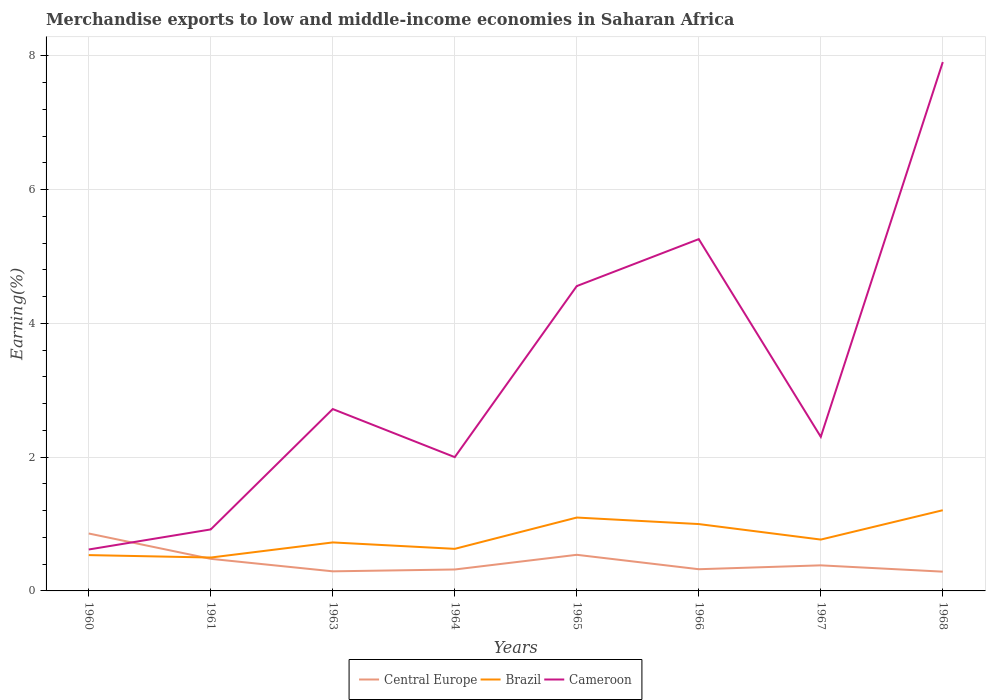Is the number of lines equal to the number of legend labels?
Your answer should be compact. Yes. Across all years, what is the maximum percentage of amount earned from merchandise exports in Cameroon?
Offer a very short reply. 0.62. What is the total percentage of amount earned from merchandise exports in Cameroon in the graph?
Your answer should be very brief. -4.34. What is the difference between the highest and the second highest percentage of amount earned from merchandise exports in Cameroon?
Give a very brief answer. 7.29. What is the difference between the highest and the lowest percentage of amount earned from merchandise exports in Cameroon?
Offer a terse response. 3. How many years are there in the graph?
Make the answer very short. 8. What is the difference between two consecutive major ticks on the Y-axis?
Offer a terse response. 2. Are the values on the major ticks of Y-axis written in scientific E-notation?
Your response must be concise. No. How are the legend labels stacked?
Ensure brevity in your answer.  Horizontal. What is the title of the graph?
Keep it short and to the point. Merchandise exports to low and middle-income economies in Saharan Africa. What is the label or title of the X-axis?
Keep it short and to the point. Years. What is the label or title of the Y-axis?
Your answer should be very brief. Earning(%). What is the Earning(%) of Central Europe in 1960?
Keep it short and to the point. 0.86. What is the Earning(%) in Brazil in 1960?
Your response must be concise. 0.54. What is the Earning(%) of Cameroon in 1960?
Provide a succinct answer. 0.62. What is the Earning(%) in Central Europe in 1961?
Give a very brief answer. 0.48. What is the Earning(%) of Brazil in 1961?
Ensure brevity in your answer.  0.5. What is the Earning(%) in Cameroon in 1961?
Your response must be concise. 0.92. What is the Earning(%) of Central Europe in 1963?
Your answer should be very brief. 0.29. What is the Earning(%) in Brazil in 1963?
Keep it short and to the point. 0.72. What is the Earning(%) of Cameroon in 1963?
Offer a terse response. 2.72. What is the Earning(%) of Central Europe in 1964?
Ensure brevity in your answer.  0.32. What is the Earning(%) in Brazil in 1964?
Offer a terse response. 0.63. What is the Earning(%) in Cameroon in 1964?
Give a very brief answer. 2. What is the Earning(%) in Central Europe in 1965?
Ensure brevity in your answer.  0.54. What is the Earning(%) of Brazil in 1965?
Provide a short and direct response. 1.1. What is the Earning(%) in Cameroon in 1965?
Provide a succinct answer. 4.56. What is the Earning(%) of Central Europe in 1966?
Make the answer very short. 0.32. What is the Earning(%) in Brazil in 1966?
Make the answer very short. 1. What is the Earning(%) of Cameroon in 1966?
Ensure brevity in your answer.  5.26. What is the Earning(%) of Central Europe in 1967?
Offer a very short reply. 0.38. What is the Earning(%) in Brazil in 1967?
Give a very brief answer. 0.77. What is the Earning(%) of Cameroon in 1967?
Your answer should be compact. 2.3. What is the Earning(%) in Central Europe in 1968?
Your answer should be very brief. 0.29. What is the Earning(%) of Brazil in 1968?
Ensure brevity in your answer.  1.21. What is the Earning(%) in Cameroon in 1968?
Provide a short and direct response. 7.91. Across all years, what is the maximum Earning(%) in Central Europe?
Your answer should be very brief. 0.86. Across all years, what is the maximum Earning(%) in Brazil?
Provide a short and direct response. 1.21. Across all years, what is the maximum Earning(%) in Cameroon?
Make the answer very short. 7.91. Across all years, what is the minimum Earning(%) in Central Europe?
Your answer should be compact. 0.29. Across all years, what is the minimum Earning(%) of Brazil?
Offer a terse response. 0.5. Across all years, what is the minimum Earning(%) of Cameroon?
Offer a very short reply. 0.62. What is the total Earning(%) in Central Europe in the graph?
Provide a succinct answer. 3.49. What is the total Earning(%) of Brazil in the graph?
Ensure brevity in your answer.  6.46. What is the total Earning(%) in Cameroon in the graph?
Your answer should be compact. 26.28. What is the difference between the Earning(%) of Central Europe in 1960 and that in 1961?
Your answer should be very brief. 0.38. What is the difference between the Earning(%) of Brazil in 1960 and that in 1961?
Provide a succinct answer. 0.04. What is the difference between the Earning(%) in Cameroon in 1960 and that in 1961?
Your answer should be compact. -0.3. What is the difference between the Earning(%) of Central Europe in 1960 and that in 1963?
Ensure brevity in your answer.  0.57. What is the difference between the Earning(%) of Brazil in 1960 and that in 1963?
Your answer should be very brief. -0.19. What is the difference between the Earning(%) of Cameroon in 1960 and that in 1963?
Provide a succinct answer. -2.1. What is the difference between the Earning(%) in Central Europe in 1960 and that in 1964?
Offer a terse response. 0.54. What is the difference between the Earning(%) in Brazil in 1960 and that in 1964?
Offer a terse response. -0.09. What is the difference between the Earning(%) in Cameroon in 1960 and that in 1964?
Offer a terse response. -1.38. What is the difference between the Earning(%) of Central Europe in 1960 and that in 1965?
Provide a succinct answer. 0.32. What is the difference between the Earning(%) of Brazil in 1960 and that in 1965?
Provide a succinct answer. -0.56. What is the difference between the Earning(%) in Cameroon in 1960 and that in 1965?
Give a very brief answer. -3.94. What is the difference between the Earning(%) in Central Europe in 1960 and that in 1966?
Give a very brief answer. 0.53. What is the difference between the Earning(%) in Brazil in 1960 and that in 1966?
Make the answer very short. -0.46. What is the difference between the Earning(%) of Cameroon in 1960 and that in 1966?
Offer a terse response. -4.64. What is the difference between the Earning(%) of Central Europe in 1960 and that in 1967?
Provide a short and direct response. 0.48. What is the difference between the Earning(%) in Brazil in 1960 and that in 1967?
Your answer should be very brief. -0.23. What is the difference between the Earning(%) in Cameroon in 1960 and that in 1967?
Ensure brevity in your answer.  -1.68. What is the difference between the Earning(%) of Central Europe in 1960 and that in 1968?
Your response must be concise. 0.57. What is the difference between the Earning(%) in Brazil in 1960 and that in 1968?
Your answer should be compact. -0.67. What is the difference between the Earning(%) of Cameroon in 1960 and that in 1968?
Make the answer very short. -7.29. What is the difference between the Earning(%) in Central Europe in 1961 and that in 1963?
Give a very brief answer. 0.19. What is the difference between the Earning(%) of Brazil in 1961 and that in 1963?
Your answer should be very brief. -0.23. What is the difference between the Earning(%) of Cameroon in 1961 and that in 1963?
Ensure brevity in your answer.  -1.8. What is the difference between the Earning(%) in Central Europe in 1961 and that in 1964?
Make the answer very short. 0.16. What is the difference between the Earning(%) of Brazil in 1961 and that in 1964?
Provide a succinct answer. -0.13. What is the difference between the Earning(%) of Cameroon in 1961 and that in 1964?
Provide a succinct answer. -1.08. What is the difference between the Earning(%) of Central Europe in 1961 and that in 1965?
Your response must be concise. -0.06. What is the difference between the Earning(%) in Brazil in 1961 and that in 1965?
Make the answer very short. -0.6. What is the difference between the Earning(%) in Cameroon in 1961 and that in 1965?
Ensure brevity in your answer.  -3.64. What is the difference between the Earning(%) of Central Europe in 1961 and that in 1966?
Give a very brief answer. 0.16. What is the difference between the Earning(%) of Brazil in 1961 and that in 1966?
Offer a very short reply. -0.5. What is the difference between the Earning(%) of Cameroon in 1961 and that in 1966?
Provide a succinct answer. -4.34. What is the difference between the Earning(%) in Central Europe in 1961 and that in 1967?
Your answer should be compact. 0.1. What is the difference between the Earning(%) of Brazil in 1961 and that in 1967?
Ensure brevity in your answer.  -0.27. What is the difference between the Earning(%) in Cameroon in 1961 and that in 1967?
Your answer should be very brief. -1.38. What is the difference between the Earning(%) in Central Europe in 1961 and that in 1968?
Keep it short and to the point. 0.19. What is the difference between the Earning(%) in Brazil in 1961 and that in 1968?
Your response must be concise. -0.71. What is the difference between the Earning(%) in Cameroon in 1961 and that in 1968?
Ensure brevity in your answer.  -6.99. What is the difference between the Earning(%) in Central Europe in 1963 and that in 1964?
Make the answer very short. -0.03. What is the difference between the Earning(%) of Brazil in 1963 and that in 1964?
Your answer should be very brief. 0.1. What is the difference between the Earning(%) in Cameroon in 1963 and that in 1964?
Give a very brief answer. 0.72. What is the difference between the Earning(%) in Central Europe in 1963 and that in 1965?
Provide a short and direct response. -0.25. What is the difference between the Earning(%) of Brazil in 1963 and that in 1965?
Provide a succinct answer. -0.37. What is the difference between the Earning(%) of Cameroon in 1963 and that in 1965?
Keep it short and to the point. -1.84. What is the difference between the Earning(%) of Central Europe in 1963 and that in 1966?
Keep it short and to the point. -0.03. What is the difference between the Earning(%) in Brazil in 1963 and that in 1966?
Your answer should be very brief. -0.27. What is the difference between the Earning(%) of Cameroon in 1963 and that in 1966?
Provide a short and direct response. -2.54. What is the difference between the Earning(%) in Central Europe in 1963 and that in 1967?
Your response must be concise. -0.09. What is the difference between the Earning(%) in Brazil in 1963 and that in 1967?
Keep it short and to the point. -0.04. What is the difference between the Earning(%) in Cameroon in 1963 and that in 1967?
Keep it short and to the point. 0.42. What is the difference between the Earning(%) of Central Europe in 1963 and that in 1968?
Provide a short and direct response. 0. What is the difference between the Earning(%) in Brazil in 1963 and that in 1968?
Provide a succinct answer. -0.48. What is the difference between the Earning(%) in Cameroon in 1963 and that in 1968?
Your response must be concise. -5.19. What is the difference between the Earning(%) in Central Europe in 1964 and that in 1965?
Provide a succinct answer. -0.22. What is the difference between the Earning(%) in Brazil in 1964 and that in 1965?
Your response must be concise. -0.47. What is the difference between the Earning(%) of Cameroon in 1964 and that in 1965?
Make the answer very short. -2.56. What is the difference between the Earning(%) of Central Europe in 1964 and that in 1966?
Make the answer very short. -0. What is the difference between the Earning(%) of Brazil in 1964 and that in 1966?
Give a very brief answer. -0.37. What is the difference between the Earning(%) in Cameroon in 1964 and that in 1966?
Ensure brevity in your answer.  -3.26. What is the difference between the Earning(%) in Central Europe in 1964 and that in 1967?
Provide a short and direct response. -0.06. What is the difference between the Earning(%) in Brazil in 1964 and that in 1967?
Your answer should be compact. -0.14. What is the difference between the Earning(%) in Cameroon in 1964 and that in 1967?
Offer a terse response. -0.3. What is the difference between the Earning(%) in Central Europe in 1964 and that in 1968?
Provide a short and direct response. 0.03. What is the difference between the Earning(%) in Brazil in 1964 and that in 1968?
Make the answer very short. -0.58. What is the difference between the Earning(%) of Cameroon in 1964 and that in 1968?
Your response must be concise. -5.91. What is the difference between the Earning(%) in Central Europe in 1965 and that in 1966?
Give a very brief answer. 0.22. What is the difference between the Earning(%) of Brazil in 1965 and that in 1966?
Your answer should be compact. 0.1. What is the difference between the Earning(%) of Cameroon in 1965 and that in 1966?
Your answer should be compact. -0.7. What is the difference between the Earning(%) of Central Europe in 1965 and that in 1967?
Provide a succinct answer. 0.16. What is the difference between the Earning(%) of Brazil in 1965 and that in 1967?
Give a very brief answer. 0.33. What is the difference between the Earning(%) of Cameroon in 1965 and that in 1967?
Offer a very short reply. 2.25. What is the difference between the Earning(%) of Central Europe in 1965 and that in 1968?
Make the answer very short. 0.25. What is the difference between the Earning(%) in Brazil in 1965 and that in 1968?
Your answer should be very brief. -0.11. What is the difference between the Earning(%) of Cameroon in 1965 and that in 1968?
Offer a terse response. -3.35. What is the difference between the Earning(%) in Central Europe in 1966 and that in 1967?
Your answer should be compact. -0.06. What is the difference between the Earning(%) of Brazil in 1966 and that in 1967?
Keep it short and to the point. 0.23. What is the difference between the Earning(%) of Cameroon in 1966 and that in 1967?
Ensure brevity in your answer.  2.96. What is the difference between the Earning(%) in Central Europe in 1966 and that in 1968?
Ensure brevity in your answer.  0.04. What is the difference between the Earning(%) in Brazil in 1966 and that in 1968?
Ensure brevity in your answer.  -0.21. What is the difference between the Earning(%) of Cameroon in 1966 and that in 1968?
Provide a succinct answer. -2.65. What is the difference between the Earning(%) of Central Europe in 1967 and that in 1968?
Keep it short and to the point. 0.09. What is the difference between the Earning(%) in Brazil in 1967 and that in 1968?
Make the answer very short. -0.44. What is the difference between the Earning(%) of Cameroon in 1967 and that in 1968?
Your response must be concise. -5.6. What is the difference between the Earning(%) of Central Europe in 1960 and the Earning(%) of Brazil in 1961?
Offer a very short reply. 0.36. What is the difference between the Earning(%) in Central Europe in 1960 and the Earning(%) in Cameroon in 1961?
Make the answer very short. -0.06. What is the difference between the Earning(%) of Brazil in 1960 and the Earning(%) of Cameroon in 1961?
Your answer should be compact. -0.38. What is the difference between the Earning(%) in Central Europe in 1960 and the Earning(%) in Brazil in 1963?
Give a very brief answer. 0.13. What is the difference between the Earning(%) of Central Europe in 1960 and the Earning(%) of Cameroon in 1963?
Offer a very short reply. -1.86. What is the difference between the Earning(%) in Brazil in 1960 and the Earning(%) in Cameroon in 1963?
Provide a short and direct response. -2.18. What is the difference between the Earning(%) of Central Europe in 1960 and the Earning(%) of Brazil in 1964?
Give a very brief answer. 0.23. What is the difference between the Earning(%) in Central Europe in 1960 and the Earning(%) in Cameroon in 1964?
Provide a short and direct response. -1.14. What is the difference between the Earning(%) of Brazil in 1960 and the Earning(%) of Cameroon in 1964?
Offer a very short reply. -1.46. What is the difference between the Earning(%) of Central Europe in 1960 and the Earning(%) of Brazil in 1965?
Keep it short and to the point. -0.24. What is the difference between the Earning(%) of Central Europe in 1960 and the Earning(%) of Cameroon in 1965?
Give a very brief answer. -3.7. What is the difference between the Earning(%) in Brazil in 1960 and the Earning(%) in Cameroon in 1965?
Keep it short and to the point. -4.02. What is the difference between the Earning(%) of Central Europe in 1960 and the Earning(%) of Brazil in 1966?
Make the answer very short. -0.14. What is the difference between the Earning(%) of Central Europe in 1960 and the Earning(%) of Cameroon in 1966?
Your answer should be compact. -4.4. What is the difference between the Earning(%) in Brazil in 1960 and the Earning(%) in Cameroon in 1966?
Keep it short and to the point. -4.72. What is the difference between the Earning(%) of Central Europe in 1960 and the Earning(%) of Brazil in 1967?
Provide a short and direct response. 0.09. What is the difference between the Earning(%) of Central Europe in 1960 and the Earning(%) of Cameroon in 1967?
Provide a succinct answer. -1.45. What is the difference between the Earning(%) in Brazil in 1960 and the Earning(%) in Cameroon in 1967?
Keep it short and to the point. -1.77. What is the difference between the Earning(%) of Central Europe in 1960 and the Earning(%) of Brazil in 1968?
Your answer should be compact. -0.35. What is the difference between the Earning(%) in Central Europe in 1960 and the Earning(%) in Cameroon in 1968?
Offer a very short reply. -7.05. What is the difference between the Earning(%) in Brazil in 1960 and the Earning(%) in Cameroon in 1968?
Keep it short and to the point. -7.37. What is the difference between the Earning(%) of Central Europe in 1961 and the Earning(%) of Brazil in 1963?
Provide a succinct answer. -0.25. What is the difference between the Earning(%) in Central Europe in 1961 and the Earning(%) in Cameroon in 1963?
Ensure brevity in your answer.  -2.24. What is the difference between the Earning(%) of Brazil in 1961 and the Earning(%) of Cameroon in 1963?
Provide a succinct answer. -2.22. What is the difference between the Earning(%) in Central Europe in 1961 and the Earning(%) in Brazil in 1964?
Make the answer very short. -0.15. What is the difference between the Earning(%) in Central Europe in 1961 and the Earning(%) in Cameroon in 1964?
Ensure brevity in your answer.  -1.52. What is the difference between the Earning(%) of Brazil in 1961 and the Earning(%) of Cameroon in 1964?
Your answer should be very brief. -1.5. What is the difference between the Earning(%) in Central Europe in 1961 and the Earning(%) in Brazil in 1965?
Provide a succinct answer. -0.62. What is the difference between the Earning(%) of Central Europe in 1961 and the Earning(%) of Cameroon in 1965?
Your answer should be compact. -4.08. What is the difference between the Earning(%) in Brazil in 1961 and the Earning(%) in Cameroon in 1965?
Your answer should be very brief. -4.06. What is the difference between the Earning(%) of Central Europe in 1961 and the Earning(%) of Brazil in 1966?
Your answer should be very brief. -0.52. What is the difference between the Earning(%) in Central Europe in 1961 and the Earning(%) in Cameroon in 1966?
Offer a very short reply. -4.78. What is the difference between the Earning(%) of Brazil in 1961 and the Earning(%) of Cameroon in 1966?
Your answer should be compact. -4.76. What is the difference between the Earning(%) in Central Europe in 1961 and the Earning(%) in Brazil in 1967?
Offer a terse response. -0.29. What is the difference between the Earning(%) in Central Europe in 1961 and the Earning(%) in Cameroon in 1967?
Keep it short and to the point. -1.82. What is the difference between the Earning(%) of Brazil in 1961 and the Earning(%) of Cameroon in 1967?
Provide a succinct answer. -1.8. What is the difference between the Earning(%) of Central Europe in 1961 and the Earning(%) of Brazil in 1968?
Keep it short and to the point. -0.73. What is the difference between the Earning(%) in Central Europe in 1961 and the Earning(%) in Cameroon in 1968?
Offer a terse response. -7.43. What is the difference between the Earning(%) in Brazil in 1961 and the Earning(%) in Cameroon in 1968?
Offer a very short reply. -7.41. What is the difference between the Earning(%) of Central Europe in 1963 and the Earning(%) of Brazil in 1964?
Your answer should be very brief. -0.34. What is the difference between the Earning(%) of Central Europe in 1963 and the Earning(%) of Cameroon in 1964?
Offer a terse response. -1.71. What is the difference between the Earning(%) in Brazil in 1963 and the Earning(%) in Cameroon in 1964?
Your answer should be compact. -1.27. What is the difference between the Earning(%) of Central Europe in 1963 and the Earning(%) of Brazil in 1965?
Offer a terse response. -0.8. What is the difference between the Earning(%) in Central Europe in 1963 and the Earning(%) in Cameroon in 1965?
Provide a short and direct response. -4.26. What is the difference between the Earning(%) in Brazil in 1963 and the Earning(%) in Cameroon in 1965?
Give a very brief answer. -3.83. What is the difference between the Earning(%) in Central Europe in 1963 and the Earning(%) in Brazil in 1966?
Offer a terse response. -0.71. What is the difference between the Earning(%) of Central Europe in 1963 and the Earning(%) of Cameroon in 1966?
Provide a succinct answer. -4.97. What is the difference between the Earning(%) of Brazil in 1963 and the Earning(%) of Cameroon in 1966?
Provide a succinct answer. -4.53. What is the difference between the Earning(%) of Central Europe in 1963 and the Earning(%) of Brazil in 1967?
Keep it short and to the point. -0.47. What is the difference between the Earning(%) in Central Europe in 1963 and the Earning(%) in Cameroon in 1967?
Ensure brevity in your answer.  -2.01. What is the difference between the Earning(%) of Brazil in 1963 and the Earning(%) of Cameroon in 1967?
Keep it short and to the point. -1.58. What is the difference between the Earning(%) in Central Europe in 1963 and the Earning(%) in Brazil in 1968?
Provide a short and direct response. -0.91. What is the difference between the Earning(%) of Central Europe in 1963 and the Earning(%) of Cameroon in 1968?
Provide a succinct answer. -7.61. What is the difference between the Earning(%) of Brazil in 1963 and the Earning(%) of Cameroon in 1968?
Give a very brief answer. -7.18. What is the difference between the Earning(%) in Central Europe in 1964 and the Earning(%) in Brazil in 1965?
Your answer should be compact. -0.78. What is the difference between the Earning(%) of Central Europe in 1964 and the Earning(%) of Cameroon in 1965?
Ensure brevity in your answer.  -4.24. What is the difference between the Earning(%) in Brazil in 1964 and the Earning(%) in Cameroon in 1965?
Your answer should be compact. -3.93. What is the difference between the Earning(%) in Central Europe in 1964 and the Earning(%) in Brazil in 1966?
Keep it short and to the point. -0.68. What is the difference between the Earning(%) of Central Europe in 1964 and the Earning(%) of Cameroon in 1966?
Your response must be concise. -4.94. What is the difference between the Earning(%) of Brazil in 1964 and the Earning(%) of Cameroon in 1966?
Your answer should be compact. -4.63. What is the difference between the Earning(%) of Central Europe in 1964 and the Earning(%) of Brazil in 1967?
Your response must be concise. -0.45. What is the difference between the Earning(%) of Central Europe in 1964 and the Earning(%) of Cameroon in 1967?
Your answer should be very brief. -1.98. What is the difference between the Earning(%) in Brazil in 1964 and the Earning(%) in Cameroon in 1967?
Give a very brief answer. -1.67. What is the difference between the Earning(%) in Central Europe in 1964 and the Earning(%) in Brazil in 1968?
Make the answer very short. -0.89. What is the difference between the Earning(%) of Central Europe in 1964 and the Earning(%) of Cameroon in 1968?
Your answer should be compact. -7.59. What is the difference between the Earning(%) of Brazil in 1964 and the Earning(%) of Cameroon in 1968?
Offer a very short reply. -7.28. What is the difference between the Earning(%) of Central Europe in 1965 and the Earning(%) of Brazil in 1966?
Your answer should be compact. -0.46. What is the difference between the Earning(%) in Central Europe in 1965 and the Earning(%) in Cameroon in 1966?
Keep it short and to the point. -4.72. What is the difference between the Earning(%) in Brazil in 1965 and the Earning(%) in Cameroon in 1966?
Offer a very short reply. -4.16. What is the difference between the Earning(%) in Central Europe in 1965 and the Earning(%) in Brazil in 1967?
Your answer should be very brief. -0.23. What is the difference between the Earning(%) of Central Europe in 1965 and the Earning(%) of Cameroon in 1967?
Make the answer very short. -1.76. What is the difference between the Earning(%) of Brazil in 1965 and the Earning(%) of Cameroon in 1967?
Provide a short and direct response. -1.21. What is the difference between the Earning(%) in Central Europe in 1965 and the Earning(%) in Brazil in 1968?
Offer a very short reply. -0.67. What is the difference between the Earning(%) of Central Europe in 1965 and the Earning(%) of Cameroon in 1968?
Keep it short and to the point. -7.37. What is the difference between the Earning(%) in Brazil in 1965 and the Earning(%) in Cameroon in 1968?
Ensure brevity in your answer.  -6.81. What is the difference between the Earning(%) in Central Europe in 1966 and the Earning(%) in Brazil in 1967?
Ensure brevity in your answer.  -0.44. What is the difference between the Earning(%) in Central Europe in 1966 and the Earning(%) in Cameroon in 1967?
Provide a short and direct response. -1.98. What is the difference between the Earning(%) of Brazil in 1966 and the Earning(%) of Cameroon in 1967?
Your answer should be compact. -1.3. What is the difference between the Earning(%) in Central Europe in 1966 and the Earning(%) in Brazil in 1968?
Offer a very short reply. -0.88. What is the difference between the Earning(%) of Central Europe in 1966 and the Earning(%) of Cameroon in 1968?
Provide a short and direct response. -7.58. What is the difference between the Earning(%) in Brazil in 1966 and the Earning(%) in Cameroon in 1968?
Offer a terse response. -6.91. What is the difference between the Earning(%) of Central Europe in 1967 and the Earning(%) of Brazil in 1968?
Give a very brief answer. -0.82. What is the difference between the Earning(%) of Central Europe in 1967 and the Earning(%) of Cameroon in 1968?
Ensure brevity in your answer.  -7.52. What is the difference between the Earning(%) of Brazil in 1967 and the Earning(%) of Cameroon in 1968?
Keep it short and to the point. -7.14. What is the average Earning(%) of Central Europe per year?
Provide a short and direct response. 0.44. What is the average Earning(%) of Brazil per year?
Your answer should be compact. 0.81. What is the average Earning(%) in Cameroon per year?
Your response must be concise. 3.29. In the year 1960, what is the difference between the Earning(%) in Central Europe and Earning(%) in Brazil?
Provide a short and direct response. 0.32. In the year 1960, what is the difference between the Earning(%) of Central Europe and Earning(%) of Cameroon?
Make the answer very short. 0.24. In the year 1960, what is the difference between the Earning(%) of Brazil and Earning(%) of Cameroon?
Keep it short and to the point. -0.08. In the year 1961, what is the difference between the Earning(%) of Central Europe and Earning(%) of Brazil?
Your answer should be compact. -0.02. In the year 1961, what is the difference between the Earning(%) in Central Europe and Earning(%) in Cameroon?
Offer a very short reply. -0.44. In the year 1961, what is the difference between the Earning(%) in Brazil and Earning(%) in Cameroon?
Offer a terse response. -0.42. In the year 1963, what is the difference between the Earning(%) in Central Europe and Earning(%) in Brazil?
Make the answer very short. -0.43. In the year 1963, what is the difference between the Earning(%) in Central Europe and Earning(%) in Cameroon?
Your answer should be very brief. -2.43. In the year 1963, what is the difference between the Earning(%) in Brazil and Earning(%) in Cameroon?
Give a very brief answer. -1.99. In the year 1964, what is the difference between the Earning(%) of Central Europe and Earning(%) of Brazil?
Ensure brevity in your answer.  -0.31. In the year 1964, what is the difference between the Earning(%) in Central Europe and Earning(%) in Cameroon?
Your answer should be compact. -1.68. In the year 1964, what is the difference between the Earning(%) in Brazil and Earning(%) in Cameroon?
Keep it short and to the point. -1.37. In the year 1965, what is the difference between the Earning(%) of Central Europe and Earning(%) of Brazil?
Offer a very short reply. -0.56. In the year 1965, what is the difference between the Earning(%) of Central Europe and Earning(%) of Cameroon?
Your answer should be very brief. -4.02. In the year 1965, what is the difference between the Earning(%) in Brazil and Earning(%) in Cameroon?
Ensure brevity in your answer.  -3.46. In the year 1966, what is the difference between the Earning(%) in Central Europe and Earning(%) in Brazil?
Provide a short and direct response. -0.68. In the year 1966, what is the difference between the Earning(%) of Central Europe and Earning(%) of Cameroon?
Offer a terse response. -4.93. In the year 1966, what is the difference between the Earning(%) of Brazil and Earning(%) of Cameroon?
Make the answer very short. -4.26. In the year 1967, what is the difference between the Earning(%) of Central Europe and Earning(%) of Brazil?
Your answer should be very brief. -0.39. In the year 1967, what is the difference between the Earning(%) in Central Europe and Earning(%) in Cameroon?
Ensure brevity in your answer.  -1.92. In the year 1967, what is the difference between the Earning(%) in Brazil and Earning(%) in Cameroon?
Offer a very short reply. -1.54. In the year 1968, what is the difference between the Earning(%) of Central Europe and Earning(%) of Brazil?
Provide a succinct answer. -0.92. In the year 1968, what is the difference between the Earning(%) of Central Europe and Earning(%) of Cameroon?
Your answer should be compact. -7.62. In the year 1968, what is the difference between the Earning(%) of Brazil and Earning(%) of Cameroon?
Provide a succinct answer. -6.7. What is the ratio of the Earning(%) in Central Europe in 1960 to that in 1961?
Offer a terse response. 1.79. What is the ratio of the Earning(%) of Brazil in 1960 to that in 1961?
Provide a succinct answer. 1.07. What is the ratio of the Earning(%) of Cameroon in 1960 to that in 1961?
Your response must be concise. 0.67. What is the ratio of the Earning(%) of Central Europe in 1960 to that in 1963?
Your answer should be compact. 2.93. What is the ratio of the Earning(%) in Brazil in 1960 to that in 1963?
Provide a short and direct response. 0.74. What is the ratio of the Earning(%) in Cameroon in 1960 to that in 1963?
Offer a very short reply. 0.23. What is the ratio of the Earning(%) of Central Europe in 1960 to that in 1964?
Ensure brevity in your answer.  2.68. What is the ratio of the Earning(%) of Brazil in 1960 to that in 1964?
Provide a short and direct response. 0.85. What is the ratio of the Earning(%) in Cameroon in 1960 to that in 1964?
Provide a short and direct response. 0.31. What is the ratio of the Earning(%) in Central Europe in 1960 to that in 1965?
Ensure brevity in your answer.  1.59. What is the ratio of the Earning(%) of Brazil in 1960 to that in 1965?
Ensure brevity in your answer.  0.49. What is the ratio of the Earning(%) of Cameroon in 1960 to that in 1965?
Ensure brevity in your answer.  0.14. What is the ratio of the Earning(%) in Central Europe in 1960 to that in 1966?
Provide a short and direct response. 2.65. What is the ratio of the Earning(%) of Brazil in 1960 to that in 1966?
Provide a succinct answer. 0.54. What is the ratio of the Earning(%) in Cameroon in 1960 to that in 1966?
Your response must be concise. 0.12. What is the ratio of the Earning(%) in Central Europe in 1960 to that in 1967?
Keep it short and to the point. 2.25. What is the ratio of the Earning(%) of Brazil in 1960 to that in 1967?
Ensure brevity in your answer.  0.7. What is the ratio of the Earning(%) in Cameroon in 1960 to that in 1967?
Provide a short and direct response. 0.27. What is the ratio of the Earning(%) in Central Europe in 1960 to that in 1968?
Your answer should be very brief. 2.98. What is the ratio of the Earning(%) in Brazil in 1960 to that in 1968?
Keep it short and to the point. 0.44. What is the ratio of the Earning(%) of Cameroon in 1960 to that in 1968?
Offer a very short reply. 0.08. What is the ratio of the Earning(%) in Central Europe in 1961 to that in 1963?
Offer a very short reply. 1.64. What is the ratio of the Earning(%) of Brazil in 1961 to that in 1963?
Provide a succinct answer. 0.69. What is the ratio of the Earning(%) in Cameroon in 1961 to that in 1963?
Provide a short and direct response. 0.34. What is the ratio of the Earning(%) in Central Europe in 1961 to that in 1964?
Make the answer very short. 1.5. What is the ratio of the Earning(%) of Brazil in 1961 to that in 1964?
Your response must be concise. 0.79. What is the ratio of the Earning(%) of Cameroon in 1961 to that in 1964?
Give a very brief answer. 0.46. What is the ratio of the Earning(%) in Central Europe in 1961 to that in 1965?
Provide a succinct answer. 0.89. What is the ratio of the Earning(%) in Brazil in 1961 to that in 1965?
Your answer should be compact. 0.46. What is the ratio of the Earning(%) in Cameroon in 1961 to that in 1965?
Your answer should be very brief. 0.2. What is the ratio of the Earning(%) in Central Europe in 1961 to that in 1966?
Provide a succinct answer. 1.48. What is the ratio of the Earning(%) in Brazil in 1961 to that in 1966?
Offer a very short reply. 0.5. What is the ratio of the Earning(%) of Cameroon in 1961 to that in 1966?
Your answer should be very brief. 0.17. What is the ratio of the Earning(%) in Central Europe in 1961 to that in 1967?
Your response must be concise. 1.25. What is the ratio of the Earning(%) in Brazil in 1961 to that in 1967?
Keep it short and to the point. 0.65. What is the ratio of the Earning(%) in Cameroon in 1961 to that in 1967?
Your answer should be compact. 0.4. What is the ratio of the Earning(%) of Central Europe in 1961 to that in 1968?
Make the answer very short. 1.67. What is the ratio of the Earning(%) in Brazil in 1961 to that in 1968?
Your response must be concise. 0.41. What is the ratio of the Earning(%) of Cameroon in 1961 to that in 1968?
Provide a short and direct response. 0.12. What is the ratio of the Earning(%) in Central Europe in 1963 to that in 1964?
Offer a very short reply. 0.91. What is the ratio of the Earning(%) in Brazil in 1963 to that in 1964?
Your answer should be compact. 1.15. What is the ratio of the Earning(%) in Cameroon in 1963 to that in 1964?
Give a very brief answer. 1.36. What is the ratio of the Earning(%) of Central Europe in 1963 to that in 1965?
Make the answer very short. 0.54. What is the ratio of the Earning(%) in Brazil in 1963 to that in 1965?
Your answer should be compact. 0.66. What is the ratio of the Earning(%) in Cameroon in 1963 to that in 1965?
Offer a terse response. 0.6. What is the ratio of the Earning(%) in Central Europe in 1963 to that in 1966?
Your response must be concise. 0.9. What is the ratio of the Earning(%) of Brazil in 1963 to that in 1966?
Your response must be concise. 0.73. What is the ratio of the Earning(%) in Cameroon in 1963 to that in 1966?
Your response must be concise. 0.52. What is the ratio of the Earning(%) of Central Europe in 1963 to that in 1967?
Make the answer very short. 0.77. What is the ratio of the Earning(%) of Brazil in 1963 to that in 1967?
Make the answer very short. 0.94. What is the ratio of the Earning(%) in Cameroon in 1963 to that in 1967?
Your answer should be compact. 1.18. What is the ratio of the Earning(%) of Central Europe in 1963 to that in 1968?
Offer a very short reply. 1.02. What is the ratio of the Earning(%) of Brazil in 1963 to that in 1968?
Ensure brevity in your answer.  0.6. What is the ratio of the Earning(%) in Cameroon in 1963 to that in 1968?
Your answer should be compact. 0.34. What is the ratio of the Earning(%) of Central Europe in 1964 to that in 1965?
Provide a short and direct response. 0.59. What is the ratio of the Earning(%) in Brazil in 1964 to that in 1965?
Your answer should be very brief. 0.57. What is the ratio of the Earning(%) of Cameroon in 1964 to that in 1965?
Your answer should be very brief. 0.44. What is the ratio of the Earning(%) of Central Europe in 1964 to that in 1966?
Keep it short and to the point. 0.99. What is the ratio of the Earning(%) in Brazil in 1964 to that in 1966?
Provide a succinct answer. 0.63. What is the ratio of the Earning(%) in Cameroon in 1964 to that in 1966?
Ensure brevity in your answer.  0.38. What is the ratio of the Earning(%) of Central Europe in 1964 to that in 1967?
Make the answer very short. 0.84. What is the ratio of the Earning(%) in Brazil in 1964 to that in 1967?
Your answer should be very brief. 0.82. What is the ratio of the Earning(%) of Cameroon in 1964 to that in 1967?
Offer a terse response. 0.87. What is the ratio of the Earning(%) in Central Europe in 1964 to that in 1968?
Your answer should be compact. 1.11. What is the ratio of the Earning(%) of Brazil in 1964 to that in 1968?
Provide a short and direct response. 0.52. What is the ratio of the Earning(%) in Cameroon in 1964 to that in 1968?
Keep it short and to the point. 0.25. What is the ratio of the Earning(%) of Central Europe in 1965 to that in 1966?
Provide a short and direct response. 1.66. What is the ratio of the Earning(%) of Brazil in 1965 to that in 1966?
Provide a short and direct response. 1.1. What is the ratio of the Earning(%) in Cameroon in 1965 to that in 1966?
Offer a terse response. 0.87. What is the ratio of the Earning(%) in Central Europe in 1965 to that in 1967?
Your answer should be very brief. 1.41. What is the ratio of the Earning(%) of Brazil in 1965 to that in 1967?
Ensure brevity in your answer.  1.43. What is the ratio of the Earning(%) of Cameroon in 1965 to that in 1967?
Provide a succinct answer. 1.98. What is the ratio of the Earning(%) of Central Europe in 1965 to that in 1968?
Provide a short and direct response. 1.87. What is the ratio of the Earning(%) in Brazil in 1965 to that in 1968?
Give a very brief answer. 0.91. What is the ratio of the Earning(%) in Cameroon in 1965 to that in 1968?
Give a very brief answer. 0.58. What is the ratio of the Earning(%) of Central Europe in 1966 to that in 1967?
Give a very brief answer. 0.85. What is the ratio of the Earning(%) of Brazil in 1966 to that in 1967?
Keep it short and to the point. 1.3. What is the ratio of the Earning(%) of Cameroon in 1966 to that in 1967?
Offer a very short reply. 2.28. What is the ratio of the Earning(%) in Central Europe in 1966 to that in 1968?
Your answer should be very brief. 1.13. What is the ratio of the Earning(%) of Brazil in 1966 to that in 1968?
Your answer should be very brief. 0.83. What is the ratio of the Earning(%) of Cameroon in 1966 to that in 1968?
Offer a very short reply. 0.67. What is the ratio of the Earning(%) in Central Europe in 1967 to that in 1968?
Keep it short and to the point. 1.33. What is the ratio of the Earning(%) in Brazil in 1967 to that in 1968?
Your answer should be compact. 0.64. What is the ratio of the Earning(%) of Cameroon in 1967 to that in 1968?
Make the answer very short. 0.29. What is the difference between the highest and the second highest Earning(%) in Central Europe?
Provide a short and direct response. 0.32. What is the difference between the highest and the second highest Earning(%) in Brazil?
Give a very brief answer. 0.11. What is the difference between the highest and the second highest Earning(%) of Cameroon?
Offer a very short reply. 2.65. What is the difference between the highest and the lowest Earning(%) of Central Europe?
Your answer should be compact. 0.57. What is the difference between the highest and the lowest Earning(%) in Brazil?
Give a very brief answer. 0.71. What is the difference between the highest and the lowest Earning(%) in Cameroon?
Give a very brief answer. 7.29. 